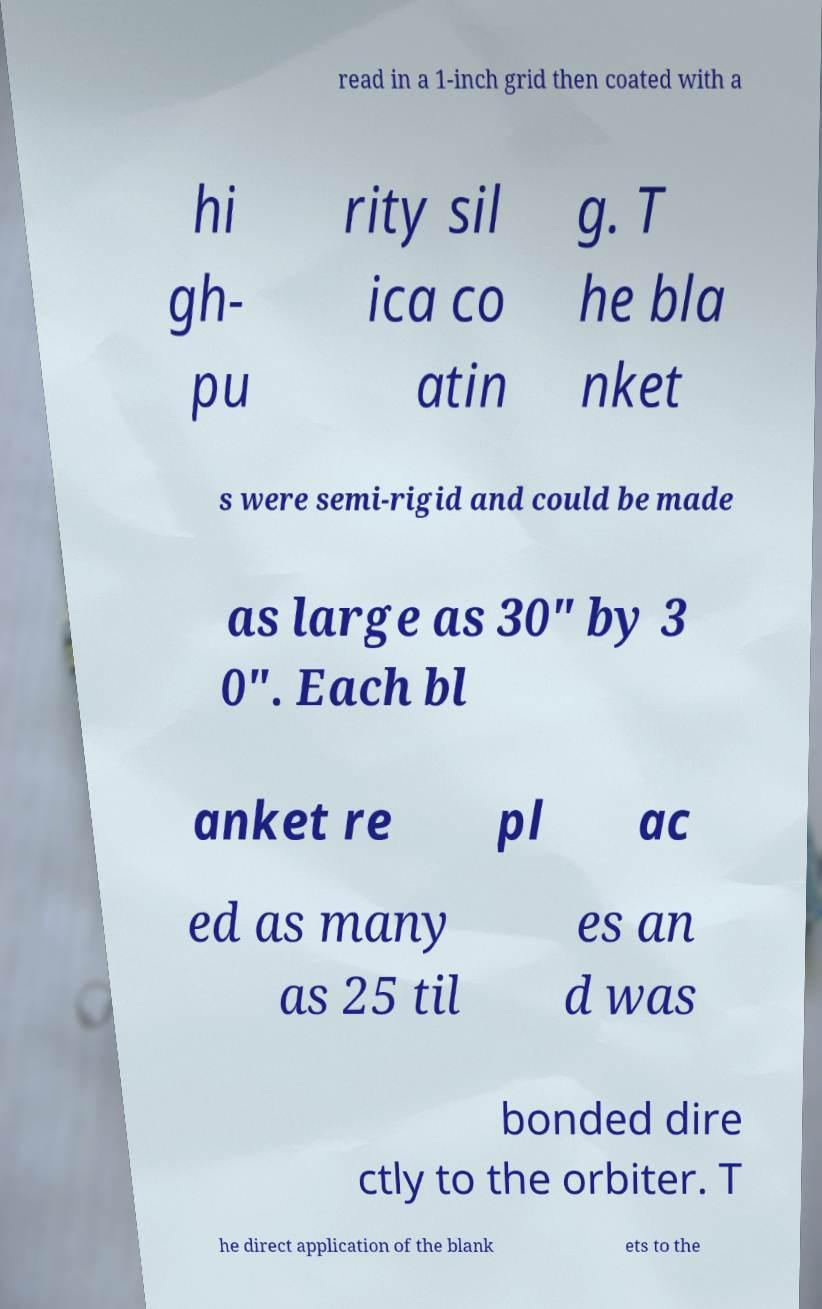Please read and relay the text visible in this image. What does it say? read in a 1-inch grid then coated with a hi gh- pu rity sil ica co atin g. T he bla nket s were semi-rigid and could be made as large as 30" by 3 0". Each bl anket re pl ac ed as many as 25 til es an d was bonded dire ctly to the orbiter. T he direct application of the blank ets to the 